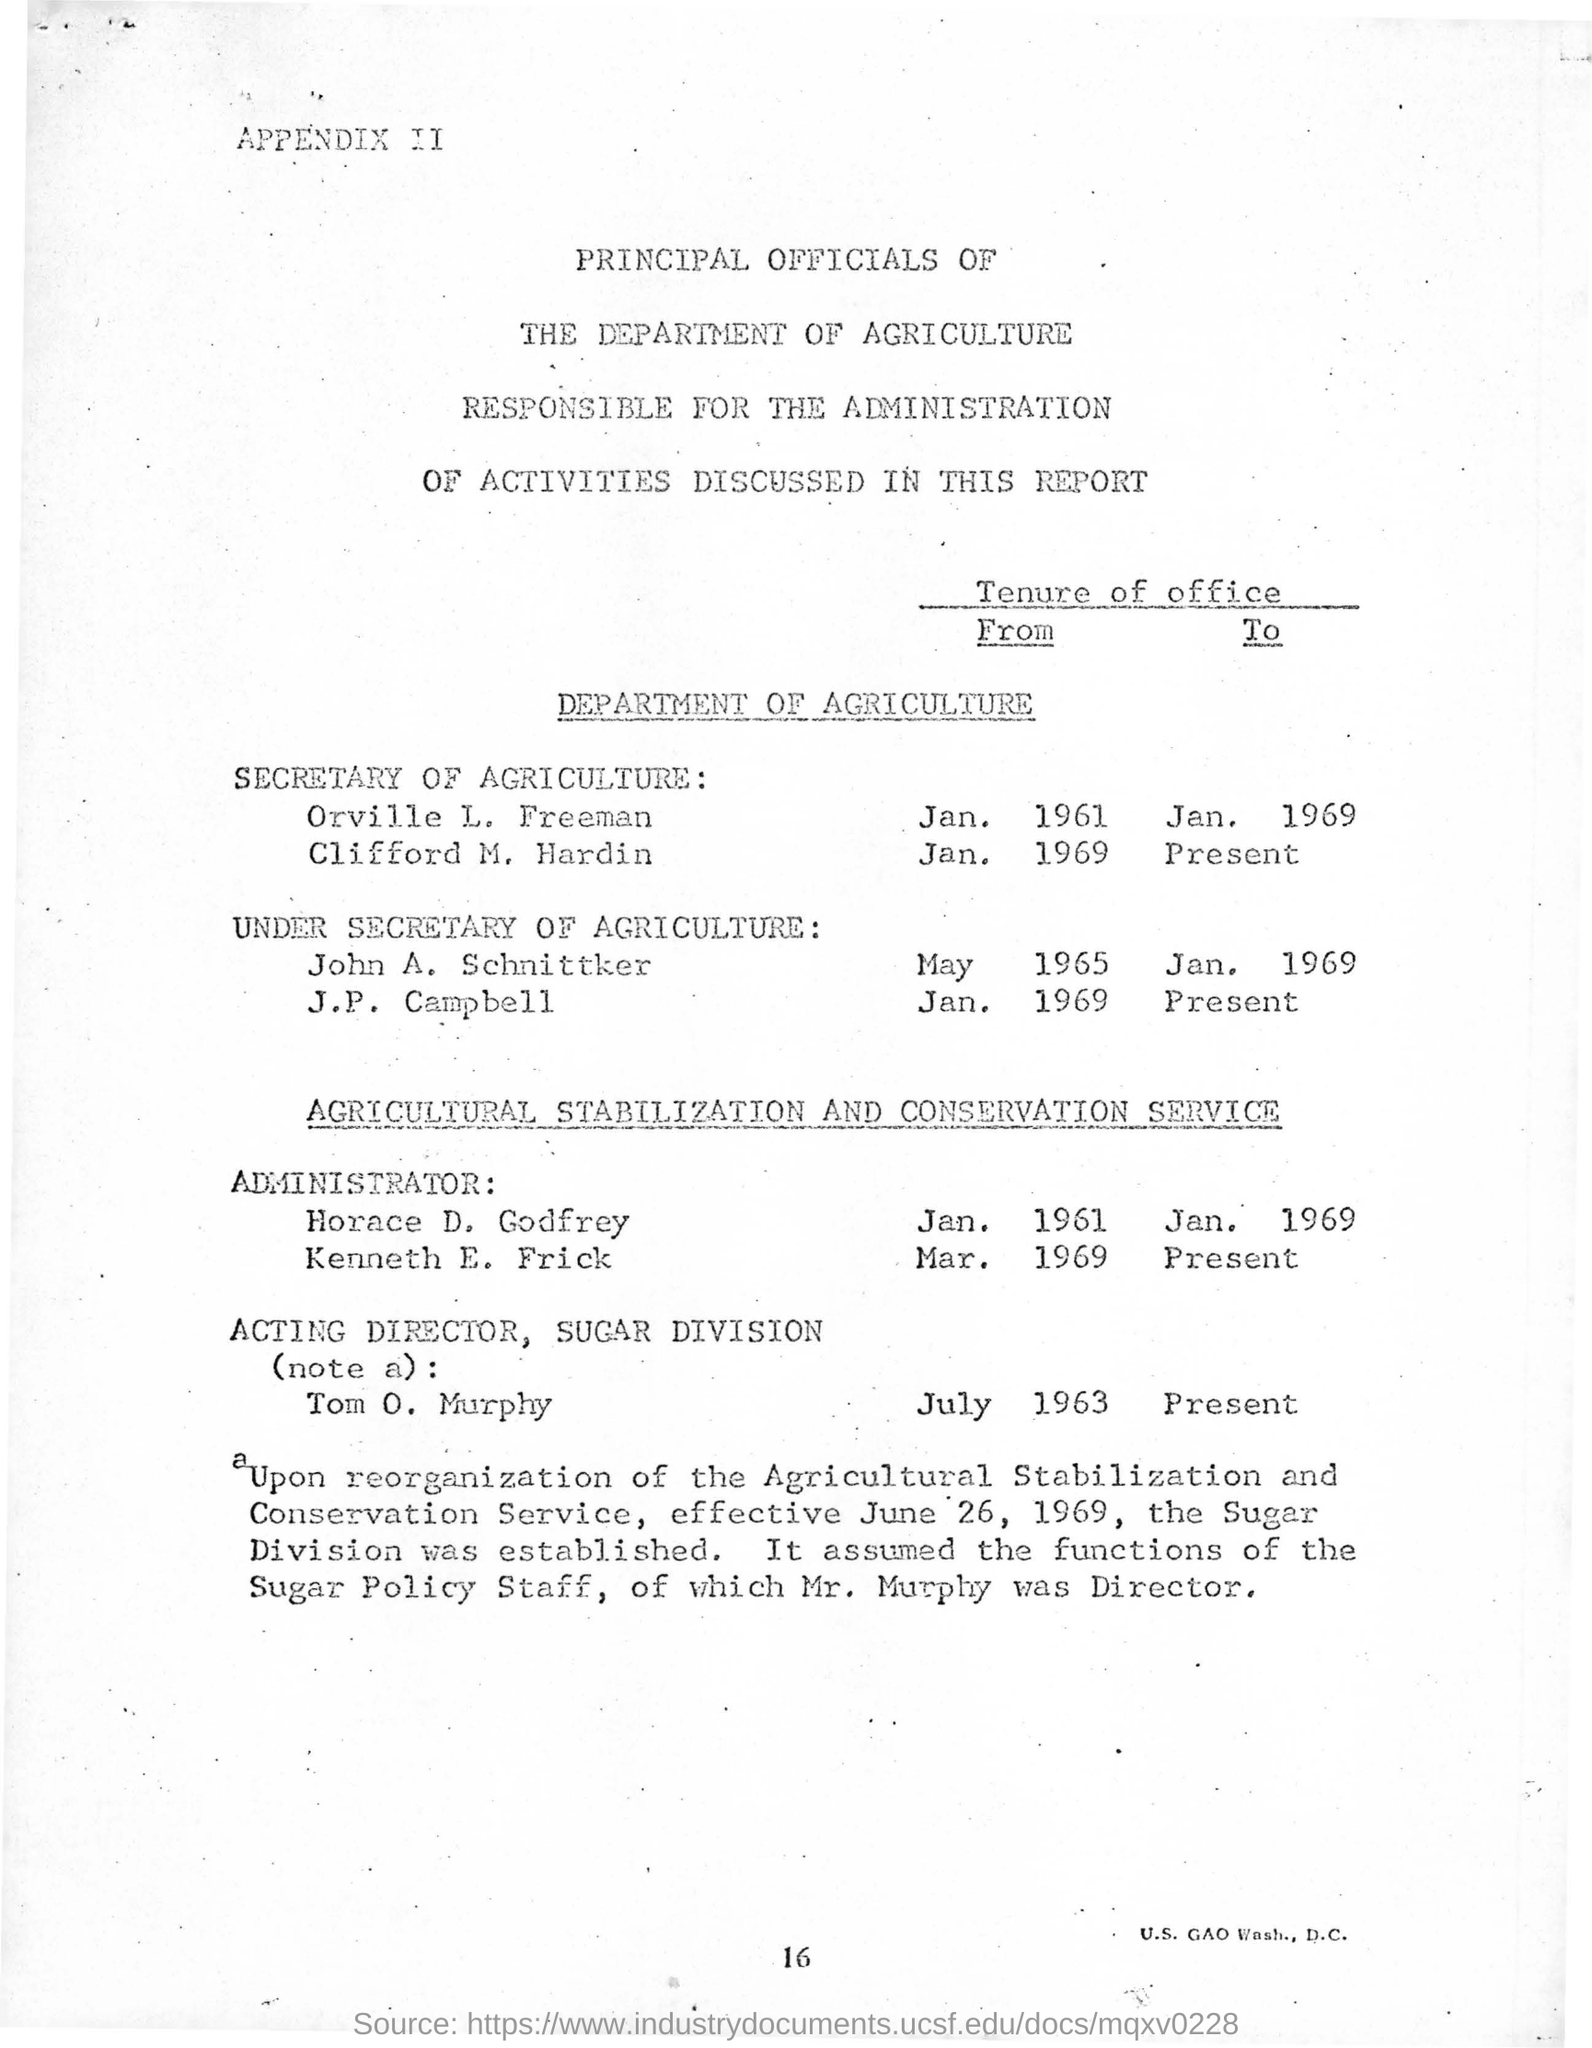Who is the Secretary of Agriculture from Jan. 1961 to Jan. 1969?
Give a very brief answer. Orville L. Freeman. Who is the Under Secretary of Agriculture from May 1965 to Jan. 1969?
Offer a very short reply. John A. Schnittker. 